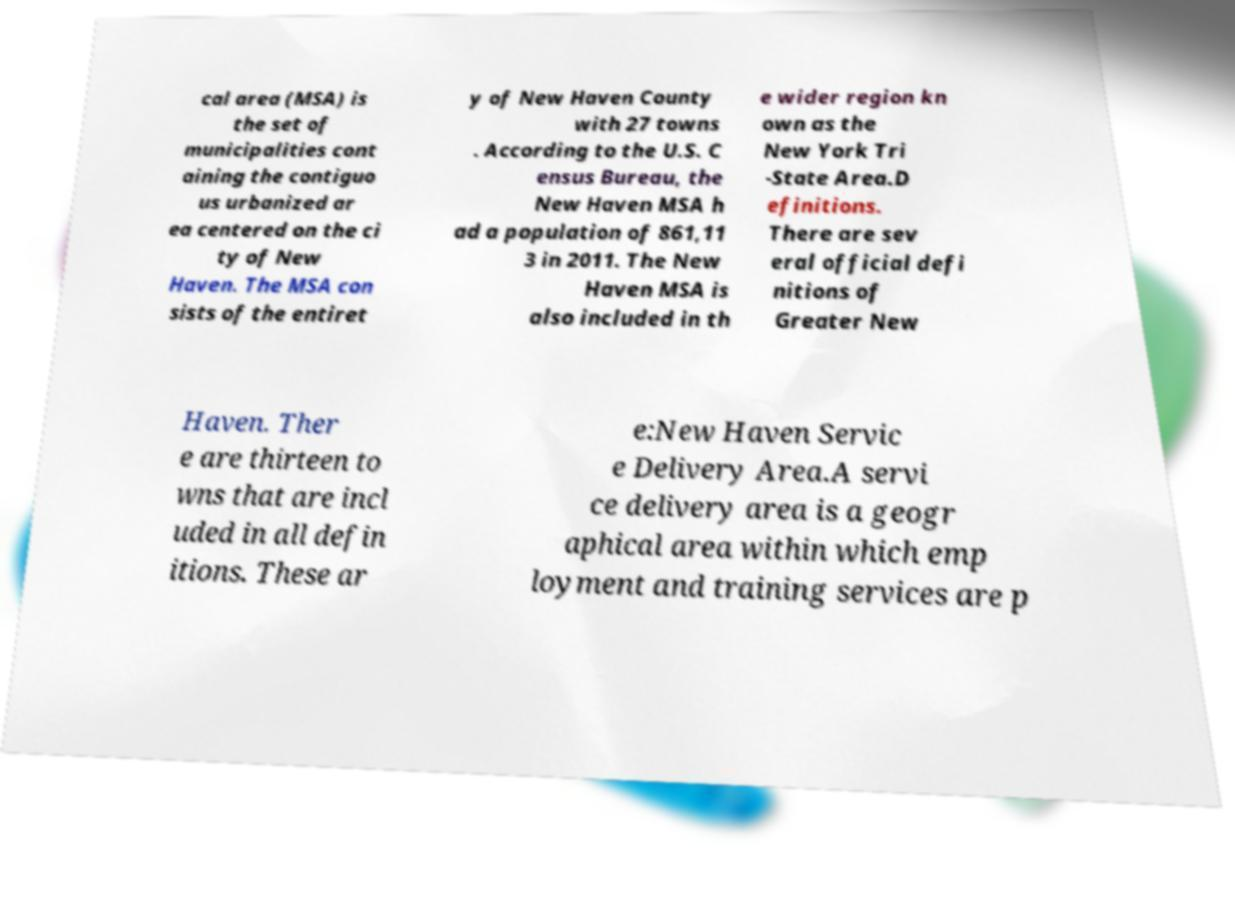What messages or text are displayed in this image? I need them in a readable, typed format. cal area (MSA) is the set of municipalities cont aining the contiguo us urbanized ar ea centered on the ci ty of New Haven. The MSA con sists of the entiret y of New Haven County with 27 towns . According to the U.S. C ensus Bureau, the New Haven MSA h ad a population of 861,11 3 in 2011. The New Haven MSA is also included in th e wider region kn own as the New York Tri -State Area.D efinitions. There are sev eral official defi nitions of Greater New Haven. Ther e are thirteen to wns that are incl uded in all defin itions. These ar e:New Haven Servic e Delivery Area.A servi ce delivery area is a geogr aphical area within which emp loyment and training services are p 